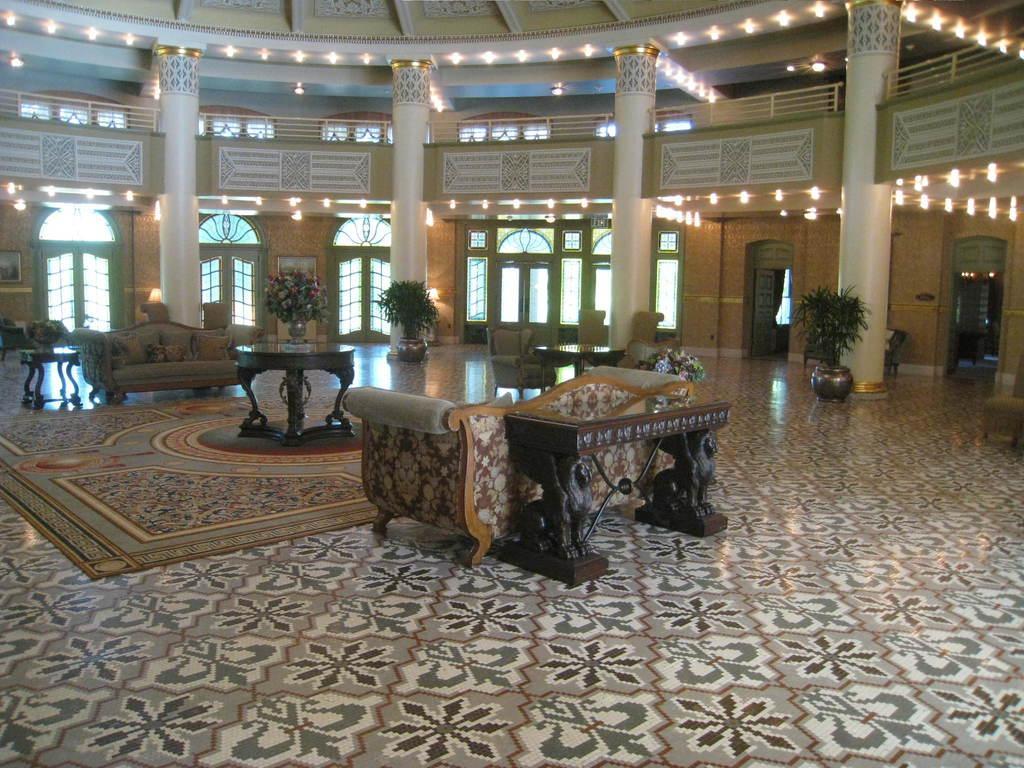How would you summarize this image in a sentence or two? In the image in the center, we can see sofas, pillows, tables and one carpet. On the tables, we can see plant pots. In the background there is a wall, roof, lights, pillars, windows, plant pots, plants, doors, fences, photo frames and a few other objects. 